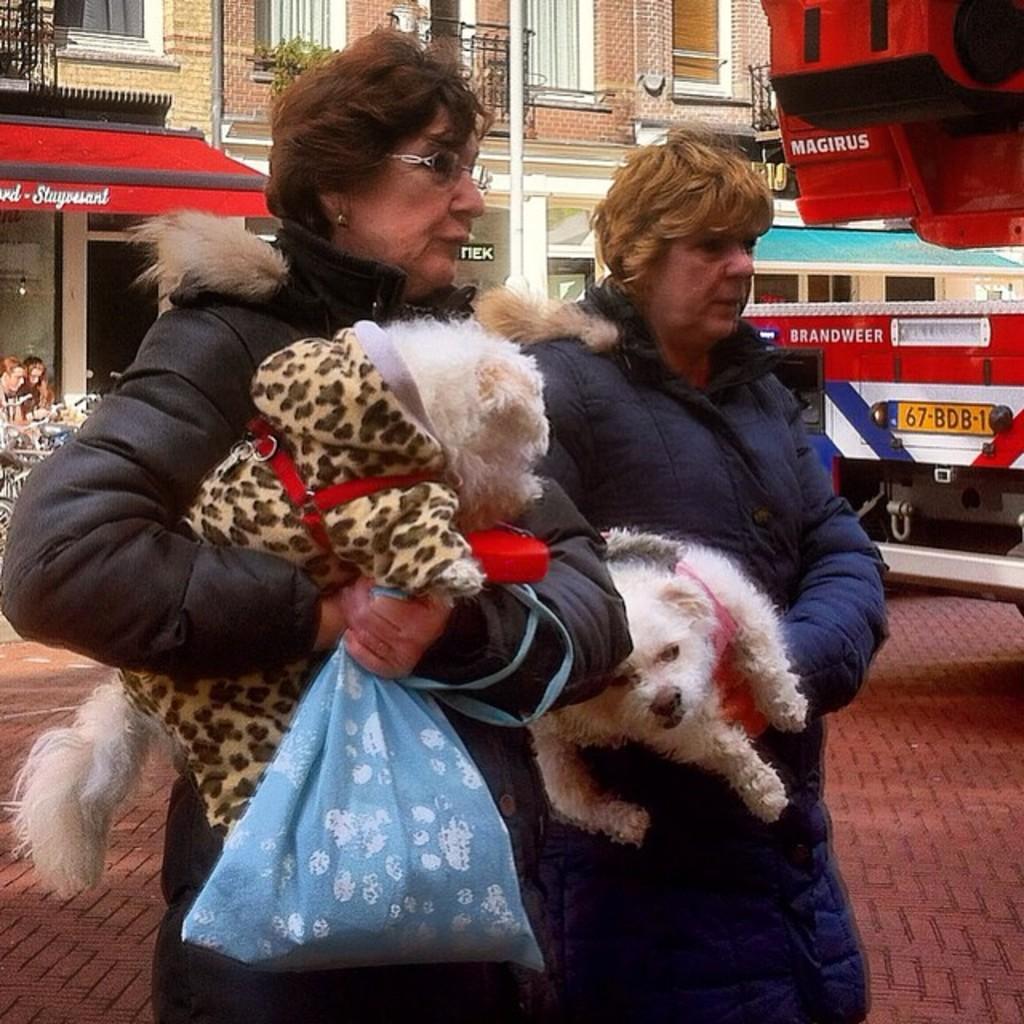How many women are in the image? There are two women in the image. What are the women doing in the image? The women are standing and holding animals. What can be seen in the background of the image? There are vehicles and buildings in the background of the image. What type of shock can be seen on the women's faces in the image? There is no indication of shock on the women's faces in the image. Can you describe the spot where the women are standing in the image? The provided facts do not give information about the specific spot where the women are standing. 